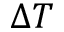<formula> <loc_0><loc_0><loc_500><loc_500>\Delta T</formula> 